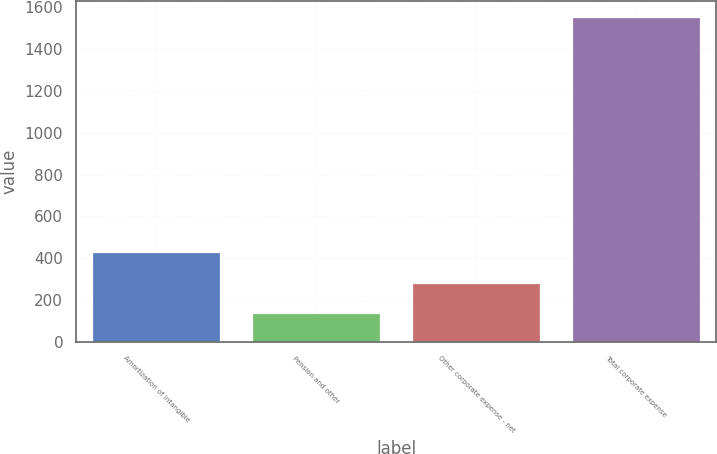<chart> <loc_0><loc_0><loc_500><loc_500><bar_chart><fcel>Amortization of intangible<fcel>Pension and other<fcel>Other corporate expense - net<fcel>Total corporate expense<nl><fcel>431<fcel>138<fcel>279.3<fcel>1551<nl></chart> 